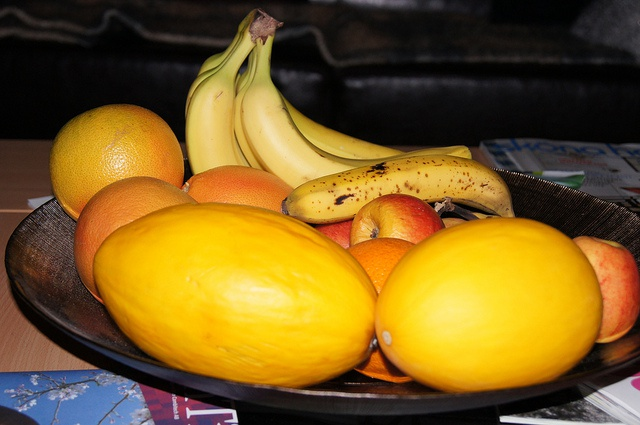Describe the objects in this image and their specific colors. I can see dining table in black, orange, gold, and olive tones, couch in black and gray tones, bowl in black, maroon, gray, and brown tones, banana in black, khaki, tan, and olive tones, and orange in black, orange, and olive tones in this image. 